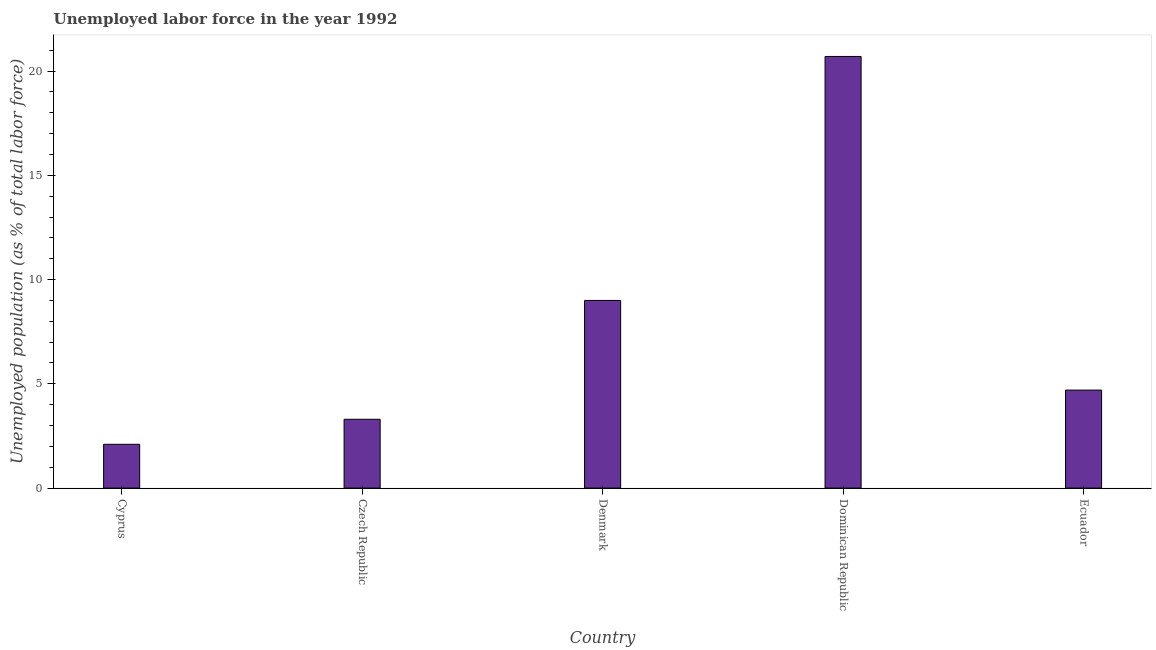Does the graph contain any zero values?
Your answer should be very brief. No. Does the graph contain grids?
Make the answer very short. No. What is the title of the graph?
Offer a terse response. Unemployed labor force in the year 1992. What is the label or title of the Y-axis?
Give a very brief answer. Unemployed population (as % of total labor force). What is the total unemployed population in Ecuador?
Ensure brevity in your answer.  4.7. Across all countries, what is the maximum total unemployed population?
Keep it short and to the point. 20.7. Across all countries, what is the minimum total unemployed population?
Ensure brevity in your answer.  2.1. In which country was the total unemployed population maximum?
Your response must be concise. Dominican Republic. In which country was the total unemployed population minimum?
Provide a succinct answer. Cyprus. What is the sum of the total unemployed population?
Provide a short and direct response. 39.8. What is the difference between the total unemployed population in Czech Republic and Dominican Republic?
Your response must be concise. -17.4. What is the average total unemployed population per country?
Your answer should be compact. 7.96. What is the median total unemployed population?
Offer a very short reply. 4.7. In how many countries, is the total unemployed population greater than 4 %?
Your answer should be very brief. 3. What is the ratio of the total unemployed population in Czech Republic to that in Dominican Republic?
Offer a very short reply. 0.16. Is the total unemployed population in Denmark less than that in Ecuador?
Offer a very short reply. No. Is the difference between the total unemployed population in Cyprus and Denmark greater than the difference between any two countries?
Offer a very short reply. No. Are all the bars in the graph horizontal?
Provide a succinct answer. No. How many countries are there in the graph?
Your response must be concise. 5. What is the difference between two consecutive major ticks on the Y-axis?
Give a very brief answer. 5. Are the values on the major ticks of Y-axis written in scientific E-notation?
Make the answer very short. No. What is the Unemployed population (as % of total labor force) of Cyprus?
Offer a very short reply. 2.1. What is the Unemployed population (as % of total labor force) of Czech Republic?
Offer a terse response. 3.3. What is the Unemployed population (as % of total labor force) in Denmark?
Your answer should be compact. 9. What is the Unemployed population (as % of total labor force) in Dominican Republic?
Make the answer very short. 20.7. What is the Unemployed population (as % of total labor force) in Ecuador?
Your answer should be compact. 4.7. What is the difference between the Unemployed population (as % of total labor force) in Cyprus and Czech Republic?
Your answer should be very brief. -1.2. What is the difference between the Unemployed population (as % of total labor force) in Cyprus and Denmark?
Your answer should be compact. -6.9. What is the difference between the Unemployed population (as % of total labor force) in Cyprus and Dominican Republic?
Your response must be concise. -18.6. What is the difference between the Unemployed population (as % of total labor force) in Czech Republic and Dominican Republic?
Your response must be concise. -17.4. What is the difference between the Unemployed population (as % of total labor force) in Denmark and Dominican Republic?
Provide a short and direct response. -11.7. What is the difference between the Unemployed population (as % of total labor force) in Dominican Republic and Ecuador?
Give a very brief answer. 16. What is the ratio of the Unemployed population (as % of total labor force) in Cyprus to that in Czech Republic?
Keep it short and to the point. 0.64. What is the ratio of the Unemployed population (as % of total labor force) in Cyprus to that in Denmark?
Give a very brief answer. 0.23. What is the ratio of the Unemployed population (as % of total labor force) in Cyprus to that in Dominican Republic?
Ensure brevity in your answer.  0.1. What is the ratio of the Unemployed population (as % of total labor force) in Cyprus to that in Ecuador?
Ensure brevity in your answer.  0.45. What is the ratio of the Unemployed population (as % of total labor force) in Czech Republic to that in Denmark?
Your answer should be compact. 0.37. What is the ratio of the Unemployed population (as % of total labor force) in Czech Republic to that in Dominican Republic?
Make the answer very short. 0.16. What is the ratio of the Unemployed population (as % of total labor force) in Czech Republic to that in Ecuador?
Keep it short and to the point. 0.7. What is the ratio of the Unemployed population (as % of total labor force) in Denmark to that in Dominican Republic?
Your answer should be compact. 0.43. What is the ratio of the Unemployed population (as % of total labor force) in Denmark to that in Ecuador?
Offer a very short reply. 1.92. What is the ratio of the Unemployed population (as % of total labor force) in Dominican Republic to that in Ecuador?
Offer a very short reply. 4.4. 